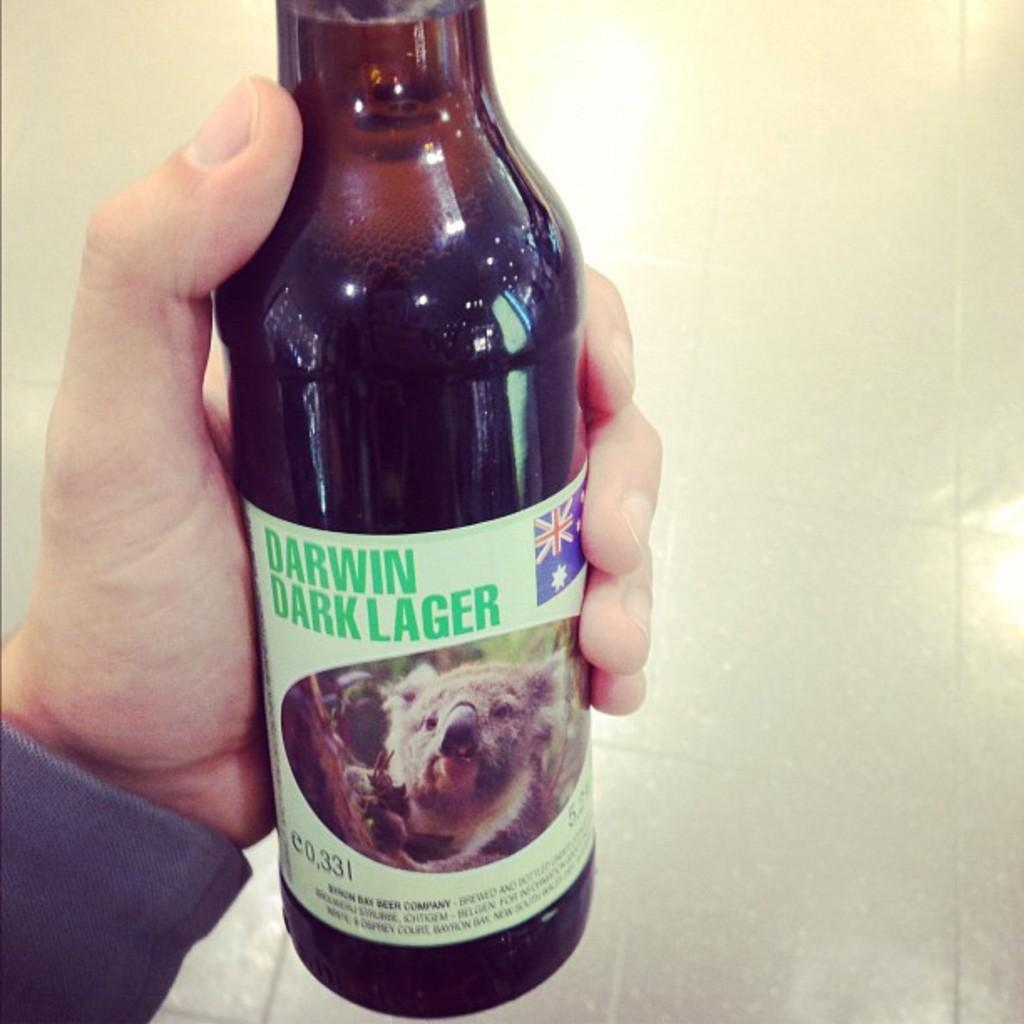What object can be seen in the image? There is a bottle in the image. How many women are present in the image? There is no information about women in the image, as the only fact provided is the presence of a bottle. 